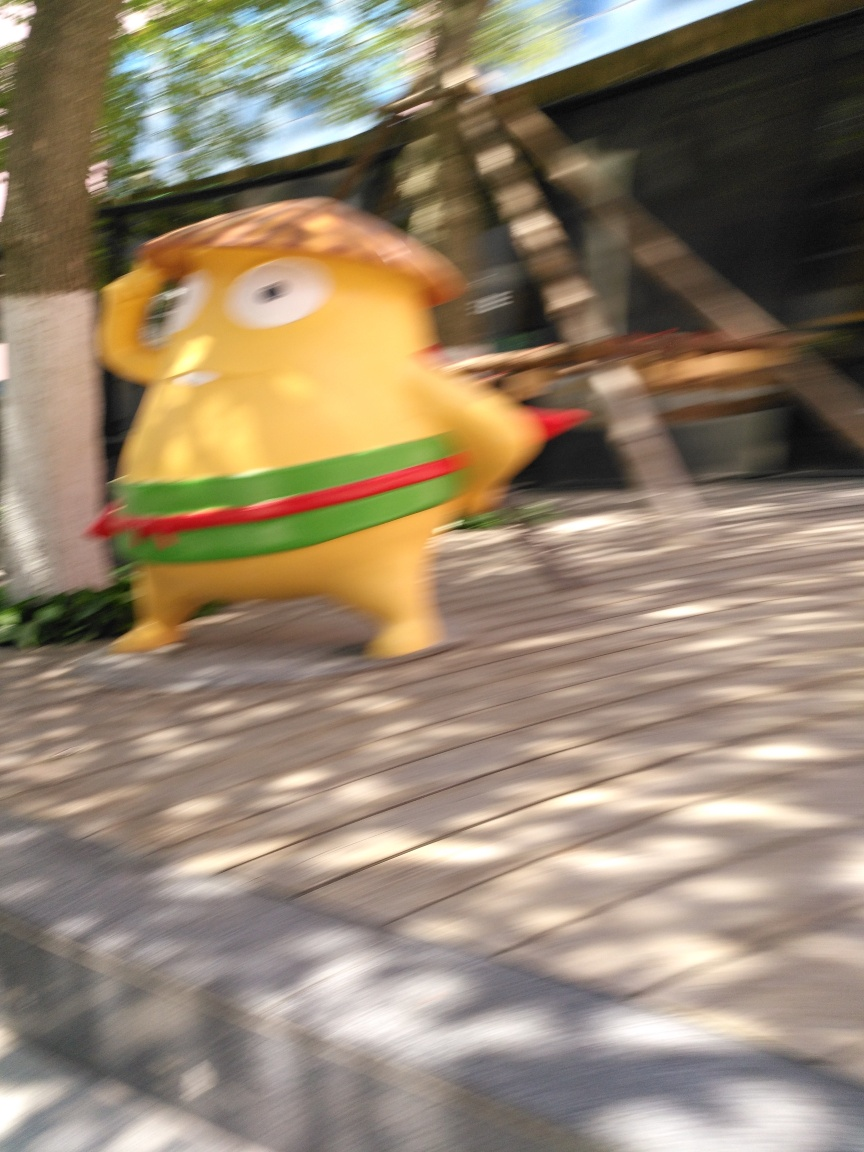What time of day does this photo suggest? The photo implies it was taken in bright daylight, as indicated by the strong shadows cast on the ground, suggesting the sun is high and casting intense light over the scene. 